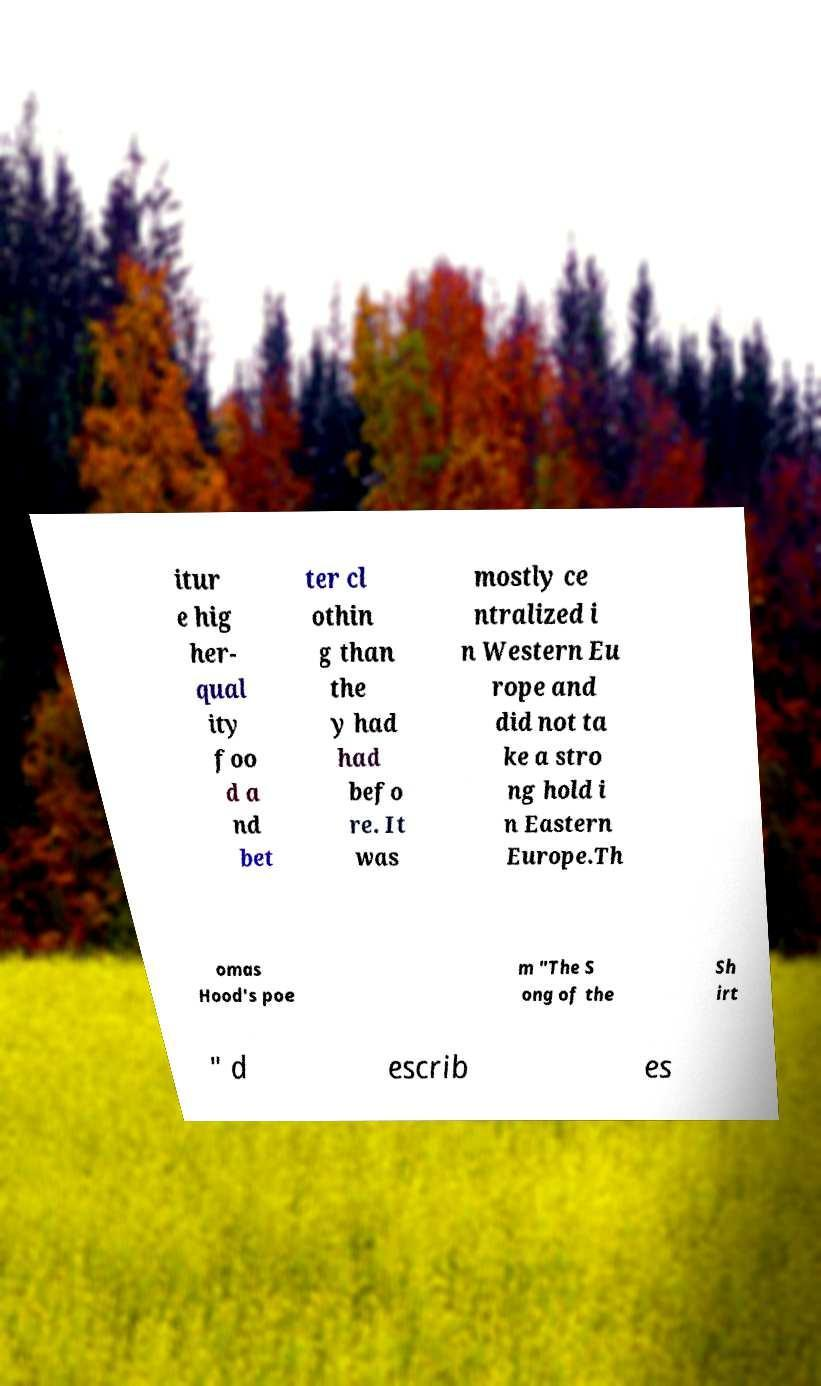There's text embedded in this image that I need extracted. Can you transcribe it verbatim? itur e hig her- qual ity foo d a nd bet ter cl othin g than the y had had befo re. It was mostly ce ntralized i n Western Eu rope and did not ta ke a stro ng hold i n Eastern Europe.Th omas Hood's poe m "The S ong of the Sh irt " d escrib es 